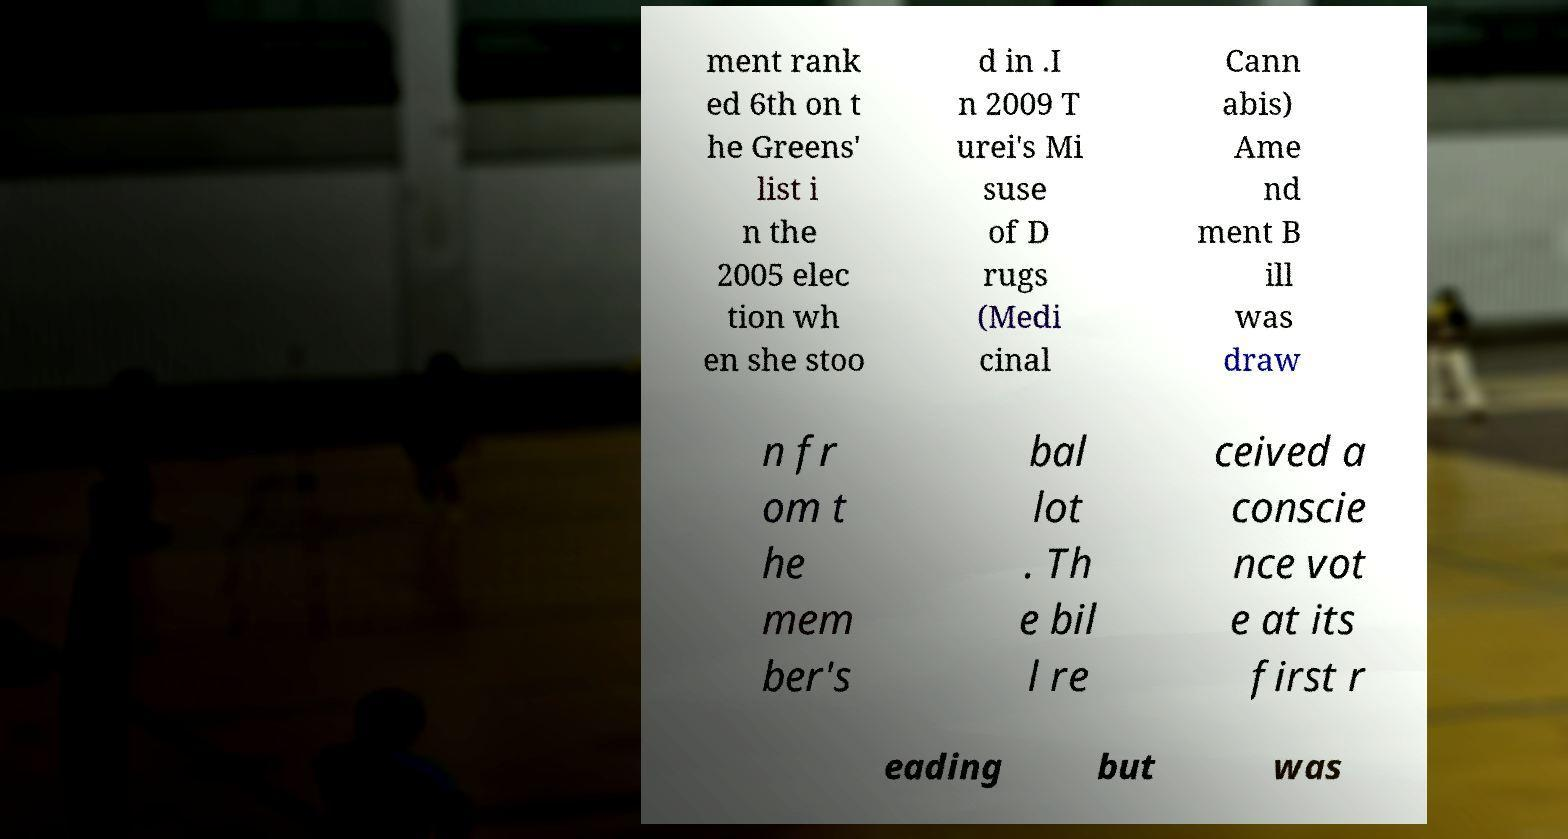Please read and relay the text visible in this image. What does it say? ment rank ed 6th on t he Greens' list i n the 2005 elec tion wh en she stoo d in .I n 2009 T urei's Mi suse of D rugs (Medi cinal Cann abis) Ame nd ment B ill was draw n fr om t he mem ber's bal lot . Th e bil l re ceived a conscie nce vot e at its first r eading but was 